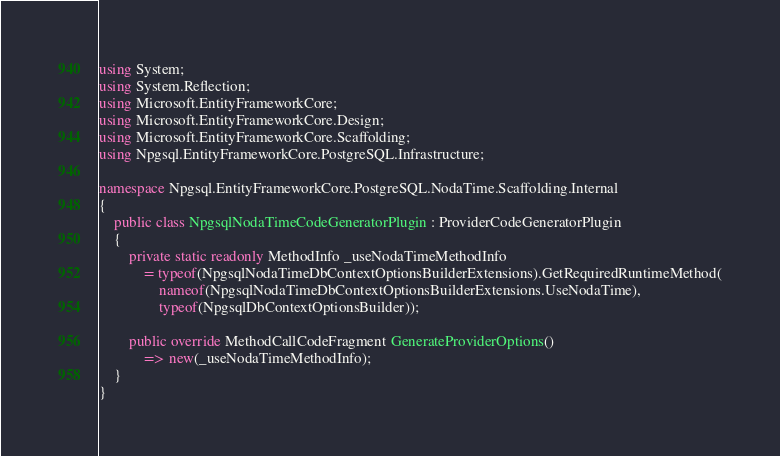<code> <loc_0><loc_0><loc_500><loc_500><_C#_>using System;
using System.Reflection;
using Microsoft.EntityFrameworkCore;
using Microsoft.EntityFrameworkCore.Design;
using Microsoft.EntityFrameworkCore.Scaffolding;
using Npgsql.EntityFrameworkCore.PostgreSQL.Infrastructure;

namespace Npgsql.EntityFrameworkCore.PostgreSQL.NodaTime.Scaffolding.Internal
{
    public class NpgsqlNodaTimeCodeGeneratorPlugin : ProviderCodeGeneratorPlugin
    {
        private static readonly MethodInfo _useNodaTimeMethodInfo
            = typeof(NpgsqlNodaTimeDbContextOptionsBuilderExtensions).GetRequiredRuntimeMethod(
                nameof(NpgsqlNodaTimeDbContextOptionsBuilderExtensions.UseNodaTime),
                typeof(NpgsqlDbContextOptionsBuilder));

        public override MethodCallCodeFragment GenerateProviderOptions()
            => new(_useNodaTimeMethodInfo);
    }
}
</code> 